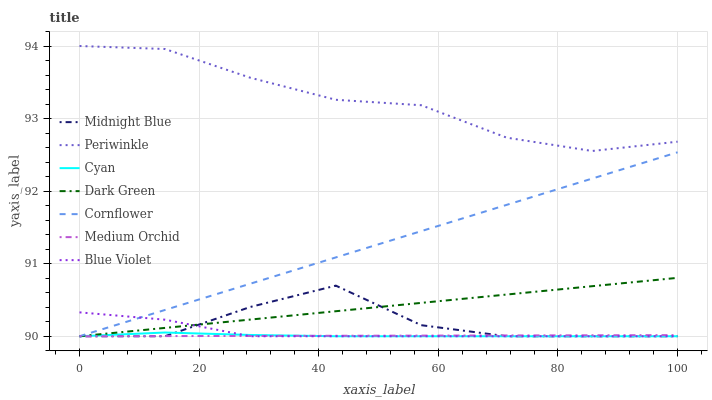Does Medium Orchid have the minimum area under the curve?
Answer yes or no. Yes. Does Periwinkle have the maximum area under the curve?
Answer yes or no. Yes. Does Midnight Blue have the minimum area under the curve?
Answer yes or no. No. Does Midnight Blue have the maximum area under the curve?
Answer yes or no. No. Is Dark Green the smoothest?
Answer yes or no. Yes. Is Midnight Blue the roughest?
Answer yes or no. Yes. Is Medium Orchid the smoothest?
Answer yes or no. No. Is Medium Orchid the roughest?
Answer yes or no. No. Does Periwinkle have the lowest value?
Answer yes or no. No. Does Periwinkle have the highest value?
Answer yes or no. Yes. Does Midnight Blue have the highest value?
Answer yes or no. No. Is Cornflower less than Periwinkle?
Answer yes or no. Yes. Is Periwinkle greater than Cyan?
Answer yes or no. Yes. Does Cyan intersect Blue Violet?
Answer yes or no. Yes. Is Cyan less than Blue Violet?
Answer yes or no. No. Is Cyan greater than Blue Violet?
Answer yes or no. No. Does Cornflower intersect Periwinkle?
Answer yes or no. No. 